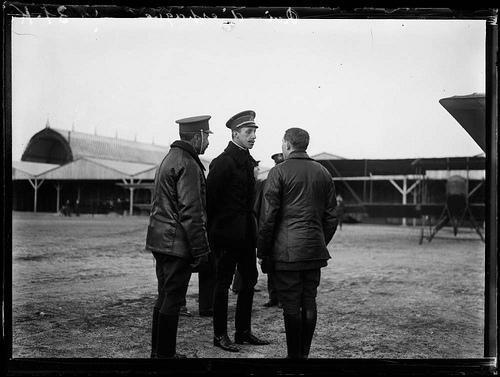How many men are there?
Give a very brief answer. 3. How many people in this photo are wearing hats?
Give a very brief answer. 2. How many people are in this photo?
Give a very brief answer. 3. How many people are there?
Give a very brief answer. 3. How many people are shown?
Give a very brief answer. 3. How many people are visible?
Give a very brief answer. 3. How many airplanes can be seen?
Give a very brief answer. 1. How many white cows are there?
Give a very brief answer. 0. 